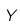<formula> <loc_0><loc_0><loc_500><loc_500>Y</formula> 